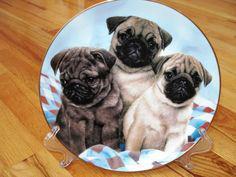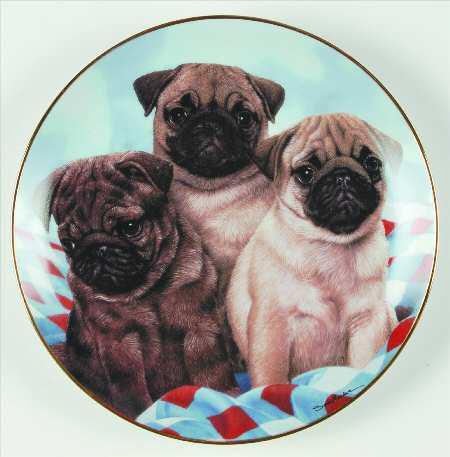The first image is the image on the left, the second image is the image on the right. Considering the images on both sides, is "Each image contains a trio of pugs and includes at least two beige pugs with dark muzzles." valid? Answer yes or no. Yes. 